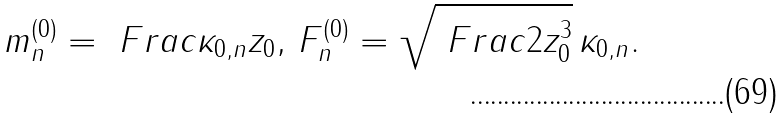<formula> <loc_0><loc_0><loc_500><loc_500>m _ { n } ^ { ( 0 ) } = \ F r a c { \kappa _ { 0 , n } } { z _ { 0 } } , \, F _ { n } ^ { ( 0 ) } = \sqrt { \ F r a c { 2 } { z _ { 0 } ^ { 3 } } } \, \kappa _ { 0 , n } .</formula> 